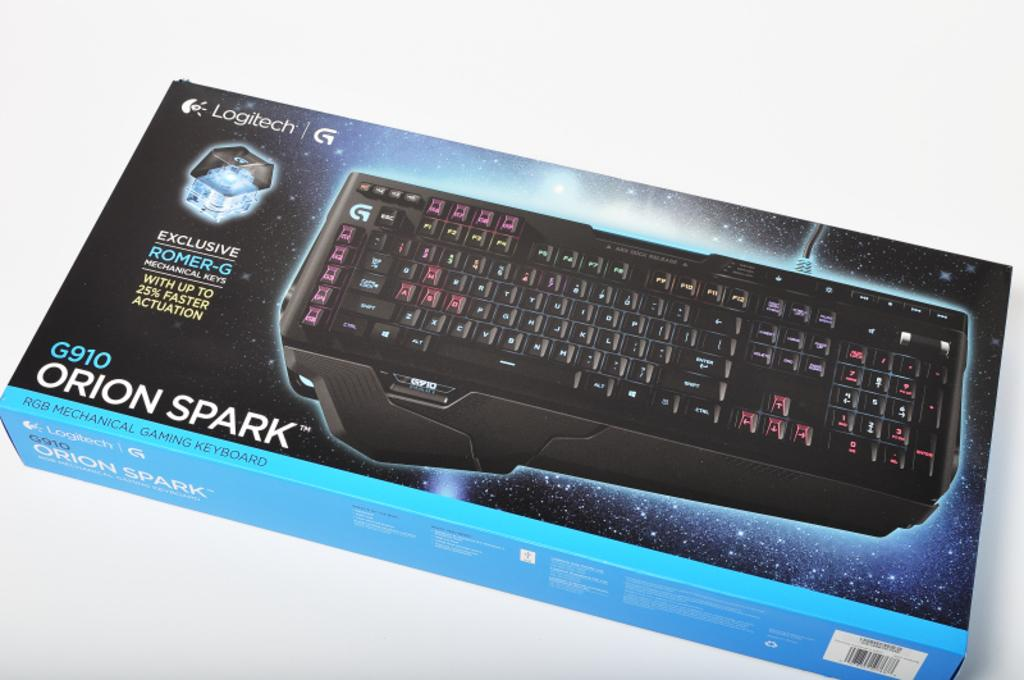Provide a one-sentence caption for the provided image. Orion Spark G910 black keyboard is made by Logitech. 